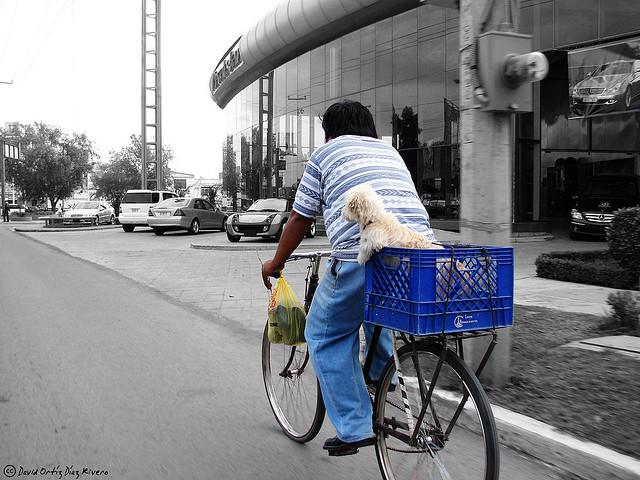Is this a safe way for a dog to travel?
Answer briefly. No. What is this dog doing?
Keep it brief. Riding. What is the dog in?
Keep it brief. Basket. 